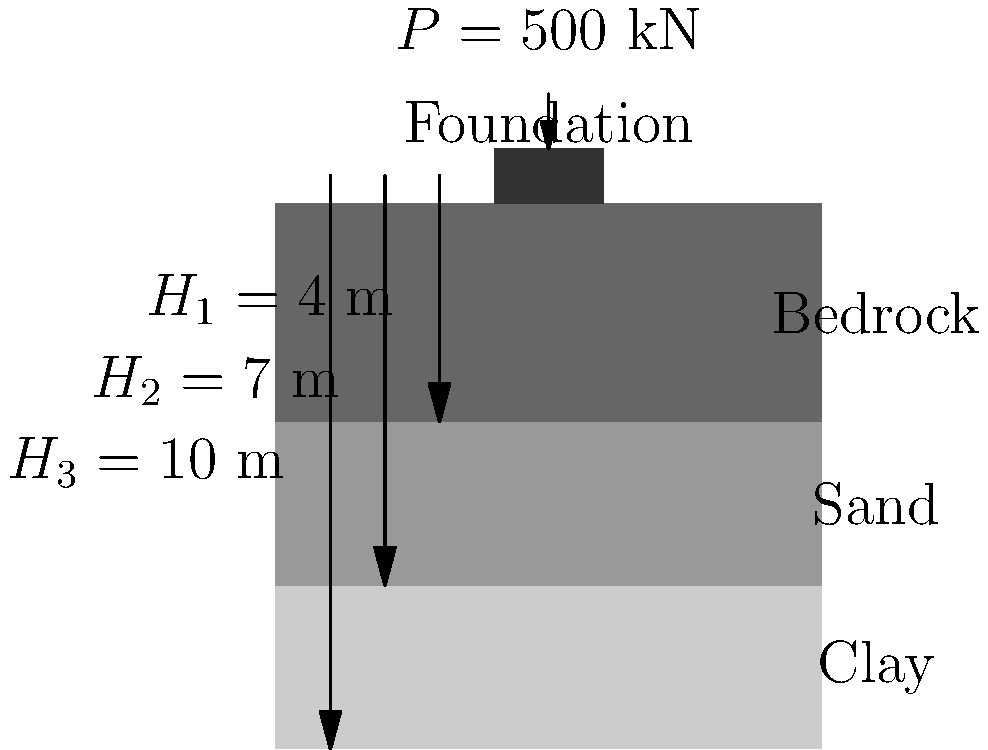A square foundation (2 m x 2 m) is placed on a layered soil profile as shown in the figure. The soil layers consist of clay (4 m thick), sand (3 m thick), and bedrock. The foundation is subjected to a vertical load of 500 kN. Given that the elastic modulus of clay is $E_1 = 20$ MPa, sand is $E_2 = 50$ MPa, and bedrock is $E_3 = 500$ MPa, calculate the total settlement of the foundation using the elastic settlement method. Assume a Poisson's ratio of 0.3 for all layers and an influence factor of 0.95. To calculate the total settlement, we'll use the elastic settlement equation for each layer and sum them up:

1) The elastic settlement equation is:
   $S = q B \frac{(1-\nu^2)}{E} I_p$

   Where:
   $S$ = Settlement
   $q$ = Applied pressure
   $B$ = Foundation width
   $\nu$ = Poisson's ratio
   $E$ = Elastic modulus
   $I_p$ = Influence factor

2) Calculate the applied pressure:
   $q = \frac{P}{A} = \frac{500 \text{ kN}}{(2 \text{ m})^2} = 125 \text{ kN/m}^2$

3) For each layer:
   Clay: $S_1 = 125 \cdot 2 \cdot \frac{(1-0.3^2)}{20 \cdot 10^6} \cdot 0.95 \cdot 4 = 0.0418 \text{ m}$
   Sand: $S_2 = 125 \cdot 2 \cdot \frac{(1-0.3^2)}{50 \cdot 10^6} \cdot 0.95 \cdot 3 = 0.0125 \text{ m}$
   Bedrock: $S_3 = 125 \cdot 2 \cdot \frac{(1-0.3^2)}{500 \cdot 10^6} \cdot 0.95 \cdot 3 = 0.0013 \text{ m}$

4) Sum up the settlements:
   $S_{\text{total}} = S_1 + S_2 + S_3 = 0.0418 + 0.0125 + 0.0013 = 0.0556 \text{ m}$

5) Convert to mm:
   $S_{\text{total}} = 0.0556 \text{ m} \cdot 1000 \text{ mm/m} = 55.6 \text{ mm}$
Answer: 55.6 mm 